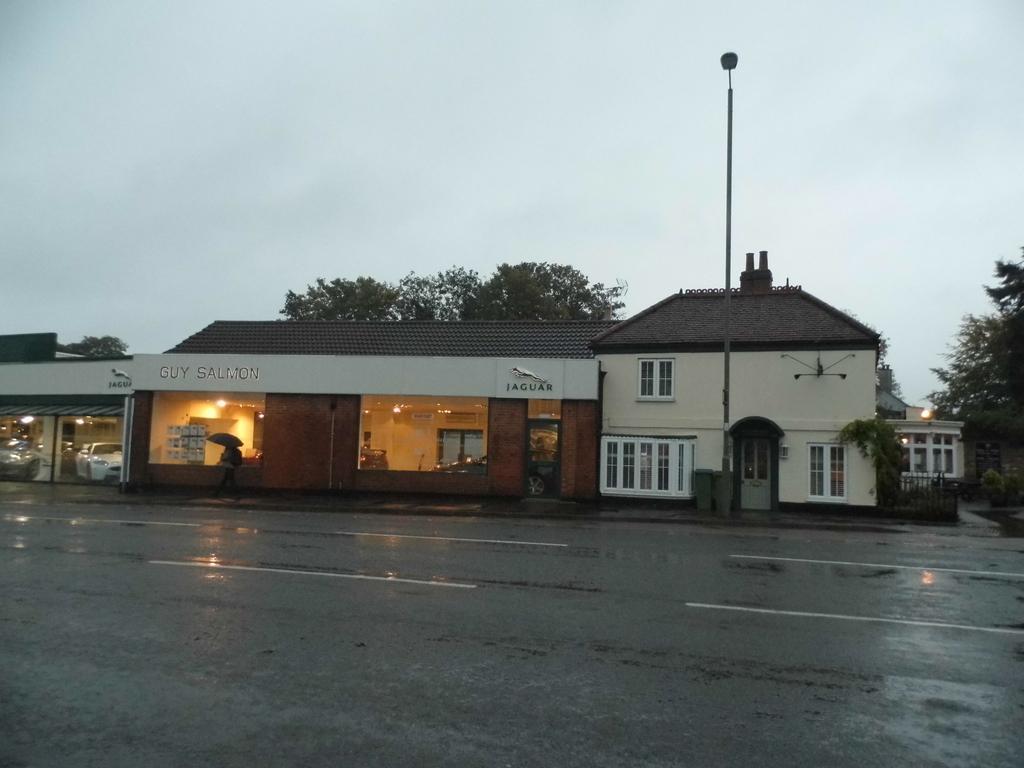In one or two sentences, can you explain what this image depicts? In this image in the middle there is a house in that there are some people, cars, lights, windows, glass and text. On the right there are trees, houseplants, street lights. At the bottom there is road. At the top there is sky. 